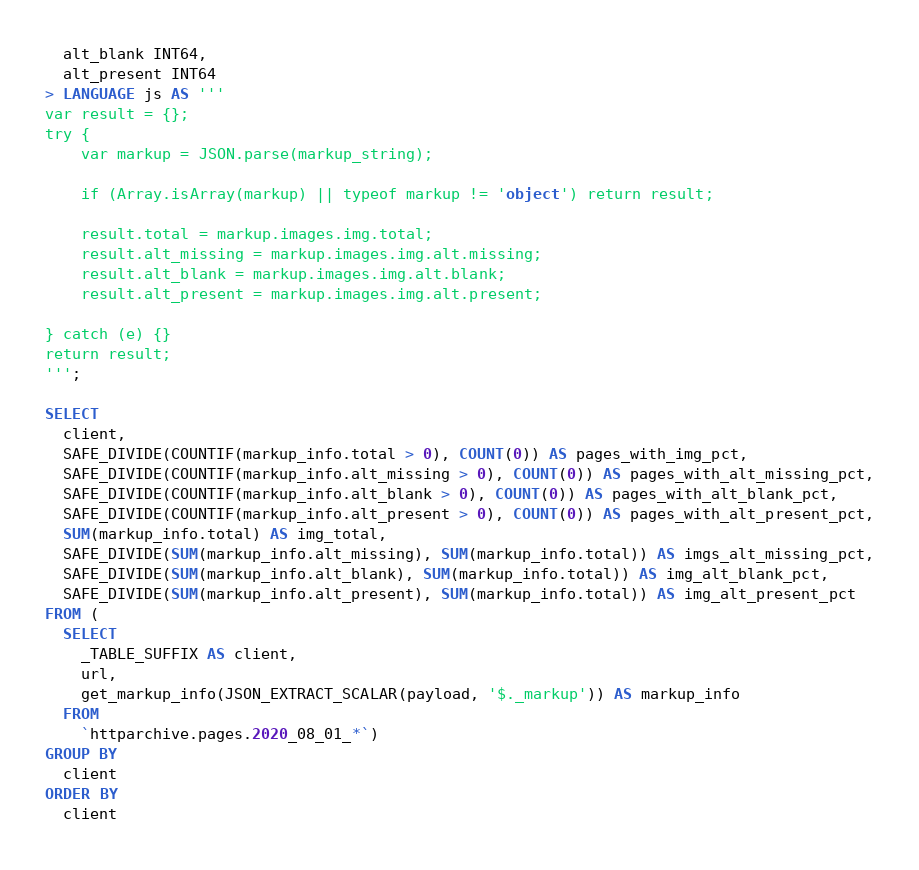Convert code to text. <code><loc_0><loc_0><loc_500><loc_500><_SQL_>  alt_blank INT64,
  alt_present INT64
> LANGUAGE js AS '''
var result = {};
try {
    var markup = JSON.parse(markup_string);

    if (Array.isArray(markup) || typeof markup != 'object') return result;

    result.total = markup.images.img.total;
    result.alt_missing = markup.images.img.alt.missing;
    result.alt_blank = markup.images.img.alt.blank;
    result.alt_present = markup.images.img.alt.present;

} catch (e) {}
return result;
''';

SELECT
  client,
  SAFE_DIVIDE(COUNTIF(markup_info.total > 0), COUNT(0)) AS pages_with_img_pct,
  SAFE_DIVIDE(COUNTIF(markup_info.alt_missing > 0), COUNT(0)) AS pages_with_alt_missing_pct,
  SAFE_DIVIDE(COUNTIF(markup_info.alt_blank > 0), COUNT(0)) AS pages_with_alt_blank_pct,
  SAFE_DIVIDE(COUNTIF(markup_info.alt_present > 0), COUNT(0)) AS pages_with_alt_present_pct,
  SUM(markup_info.total) AS img_total,
  SAFE_DIVIDE(SUM(markup_info.alt_missing), SUM(markup_info.total)) AS imgs_alt_missing_pct,
  SAFE_DIVIDE(SUM(markup_info.alt_blank), SUM(markup_info.total)) AS img_alt_blank_pct,
  SAFE_DIVIDE(SUM(markup_info.alt_present), SUM(markup_info.total)) AS img_alt_present_pct
FROM (
  SELECT
    _TABLE_SUFFIX AS client,
    url,
    get_markup_info(JSON_EXTRACT_SCALAR(payload, '$._markup')) AS markup_info
  FROM
    `httparchive.pages.2020_08_01_*`)
GROUP BY
  client
ORDER BY
  client
</code> 